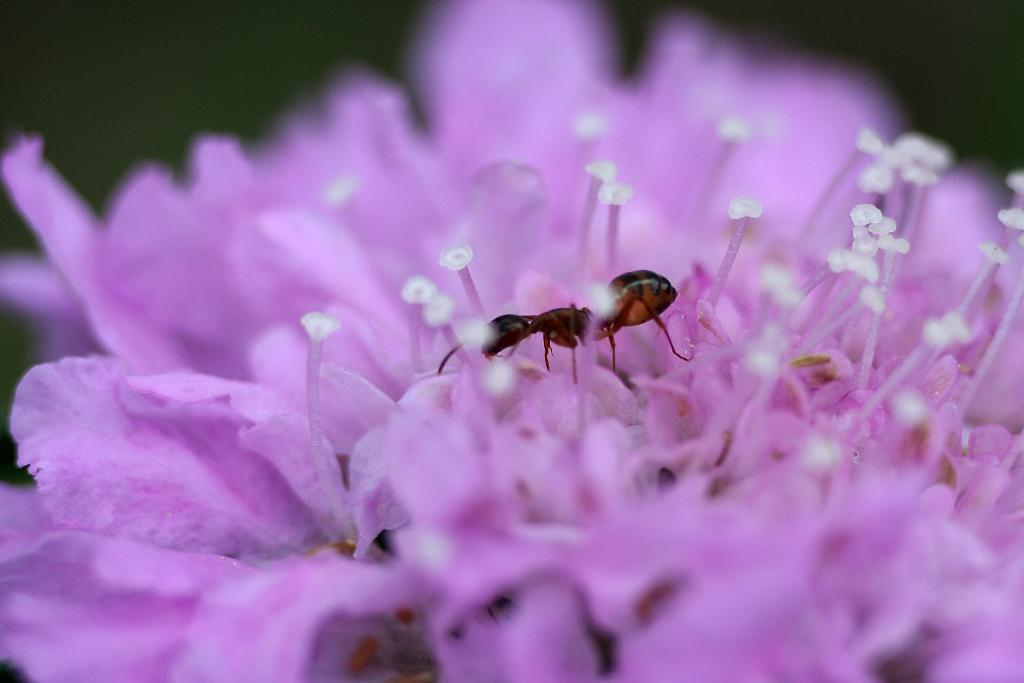What is present in the image? There is an insect in the image. Where is the insect located? The insect is on a purple flower. What type of cushion is the insect using for its voyage in the image? There is no cushion or voyage present in the image; it simply shows an insect on a purple flower. 